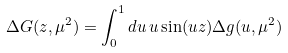<formula> <loc_0><loc_0><loc_500><loc_500>\Delta G ( z , \mu ^ { 2 } ) = \int ^ { 1 } _ { 0 } d u \, u \sin ( u z ) \Delta g ( u , \mu ^ { 2 } )</formula> 